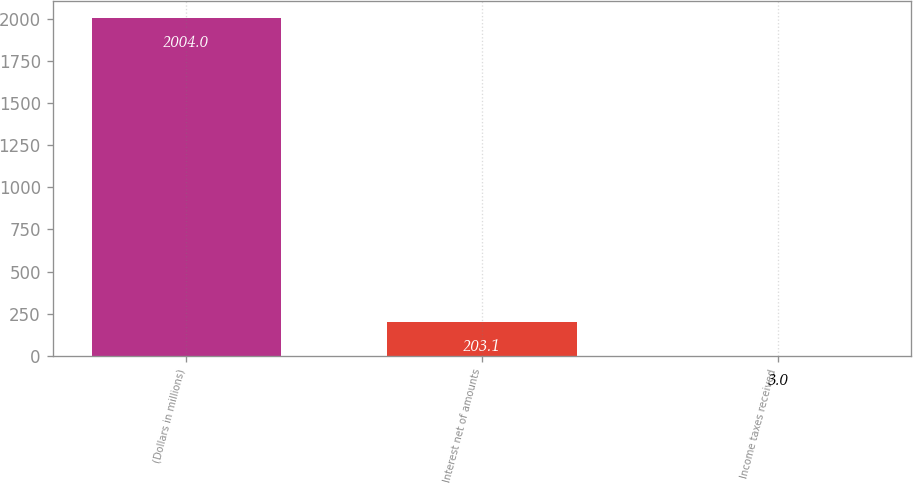Convert chart. <chart><loc_0><loc_0><loc_500><loc_500><bar_chart><fcel>(Dollars in millions)<fcel>Interest net of amounts<fcel>Income taxes received<nl><fcel>2004<fcel>203.1<fcel>3<nl></chart> 